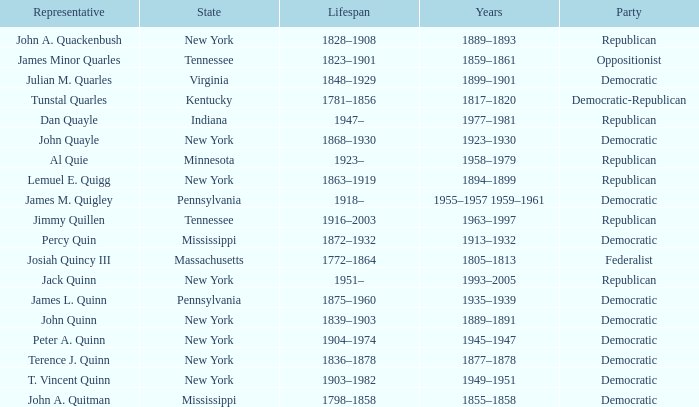What is the lifespan of the democratic party in New York, for which Terence J. Quinn is a representative? 1836–1878. 